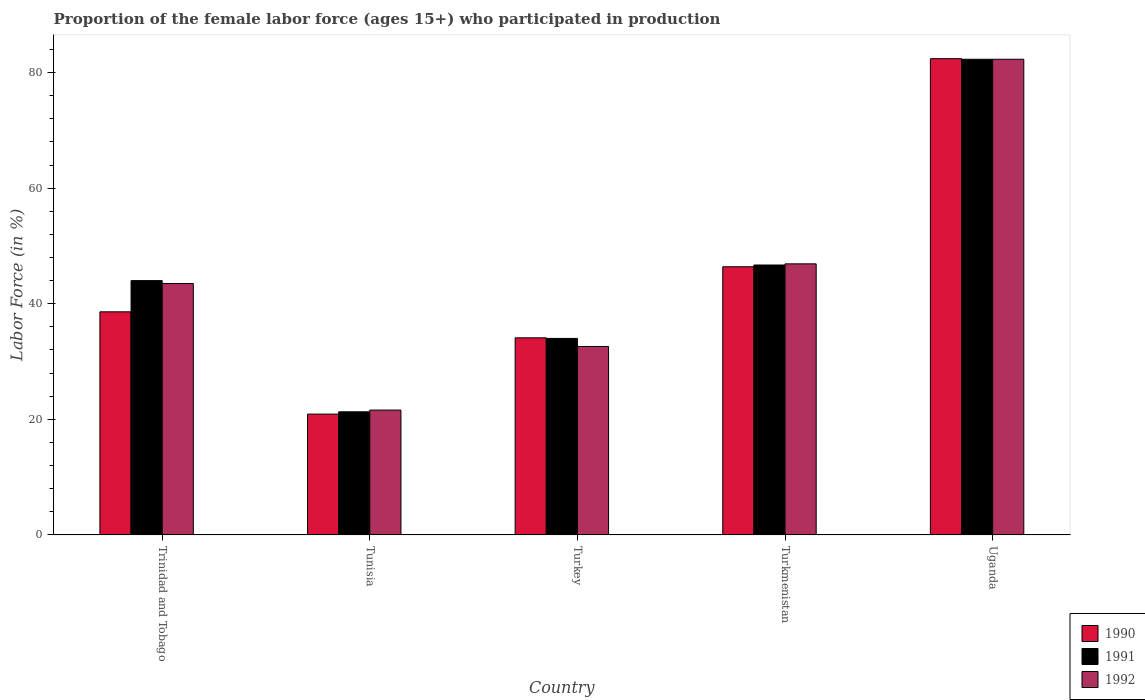How many different coloured bars are there?
Offer a very short reply. 3. How many groups of bars are there?
Keep it short and to the point. 5. What is the label of the 2nd group of bars from the left?
Your answer should be very brief. Tunisia. In how many cases, is the number of bars for a given country not equal to the number of legend labels?
Offer a terse response. 0. What is the proportion of the female labor force who participated in production in 1991 in Tunisia?
Your response must be concise. 21.3. Across all countries, what is the maximum proportion of the female labor force who participated in production in 1992?
Offer a terse response. 82.3. Across all countries, what is the minimum proportion of the female labor force who participated in production in 1990?
Keep it short and to the point. 20.9. In which country was the proportion of the female labor force who participated in production in 1991 maximum?
Offer a very short reply. Uganda. In which country was the proportion of the female labor force who participated in production in 1990 minimum?
Ensure brevity in your answer.  Tunisia. What is the total proportion of the female labor force who participated in production in 1991 in the graph?
Give a very brief answer. 228.3. What is the difference between the proportion of the female labor force who participated in production in 1992 in Turkey and that in Turkmenistan?
Your response must be concise. -14.3. What is the difference between the proportion of the female labor force who participated in production in 1990 in Trinidad and Tobago and the proportion of the female labor force who participated in production in 1991 in Turkmenistan?
Provide a succinct answer. -8.1. What is the average proportion of the female labor force who participated in production in 1990 per country?
Make the answer very short. 44.48. What is the difference between the proportion of the female labor force who participated in production of/in 1991 and proportion of the female labor force who participated in production of/in 1992 in Turkey?
Keep it short and to the point. 1.4. In how many countries, is the proportion of the female labor force who participated in production in 1992 greater than 4 %?
Make the answer very short. 5. What is the ratio of the proportion of the female labor force who participated in production in 1991 in Turkey to that in Uganda?
Make the answer very short. 0.41. Is the proportion of the female labor force who participated in production in 1991 in Turkey less than that in Turkmenistan?
Give a very brief answer. Yes. What is the difference between the highest and the second highest proportion of the female labor force who participated in production in 1991?
Give a very brief answer. 38.3. What is the difference between the highest and the lowest proportion of the female labor force who participated in production in 1990?
Ensure brevity in your answer.  61.5. What does the 1st bar from the right in Trinidad and Tobago represents?
Offer a very short reply. 1992. Is it the case that in every country, the sum of the proportion of the female labor force who participated in production in 1992 and proportion of the female labor force who participated in production in 1990 is greater than the proportion of the female labor force who participated in production in 1991?
Provide a short and direct response. Yes. Are all the bars in the graph horizontal?
Provide a short and direct response. No. How many countries are there in the graph?
Offer a terse response. 5. Does the graph contain any zero values?
Offer a terse response. No. Where does the legend appear in the graph?
Provide a succinct answer. Bottom right. How many legend labels are there?
Your answer should be very brief. 3. How are the legend labels stacked?
Make the answer very short. Vertical. What is the title of the graph?
Give a very brief answer. Proportion of the female labor force (ages 15+) who participated in production. Does "1965" appear as one of the legend labels in the graph?
Your answer should be compact. No. What is the label or title of the X-axis?
Offer a very short reply. Country. What is the Labor Force (in %) of 1990 in Trinidad and Tobago?
Offer a very short reply. 38.6. What is the Labor Force (in %) of 1992 in Trinidad and Tobago?
Offer a terse response. 43.5. What is the Labor Force (in %) in 1990 in Tunisia?
Ensure brevity in your answer.  20.9. What is the Labor Force (in %) of 1991 in Tunisia?
Provide a short and direct response. 21.3. What is the Labor Force (in %) of 1992 in Tunisia?
Make the answer very short. 21.6. What is the Labor Force (in %) of 1990 in Turkey?
Keep it short and to the point. 34.1. What is the Labor Force (in %) of 1991 in Turkey?
Ensure brevity in your answer.  34. What is the Labor Force (in %) in 1992 in Turkey?
Ensure brevity in your answer.  32.6. What is the Labor Force (in %) in 1990 in Turkmenistan?
Your answer should be very brief. 46.4. What is the Labor Force (in %) of 1991 in Turkmenistan?
Provide a short and direct response. 46.7. What is the Labor Force (in %) of 1992 in Turkmenistan?
Your answer should be compact. 46.9. What is the Labor Force (in %) in 1990 in Uganda?
Provide a succinct answer. 82.4. What is the Labor Force (in %) in 1991 in Uganda?
Provide a succinct answer. 82.3. What is the Labor Force (in %) in 1992 in Uganda?
Your answer should be very brief. 82.3. Across all countries, what is the maximum Labor Force (in %) in 1990?
Provide a succinct answer. 82.4. Across all countries, what is the maximum Labor Force (in %) in 1991?
Your answer should be compact. 82.3. Across all countries, what is the maximum Labor Force (in %) in 1992?
Your answer should be very brief. 82.3. Across all countries, what is the minimum Labor Force (in %) in 1990?
Make the answer very short. 20.9. Across all countries, what is the minimum Labor Force (in %) in 1991?
Keep it short and to the point. 21.3. Across all countries, what is the minimum Labor Force (in %) of 1992?
Your response must be concise. 21.6. What is the total Labor Force (in %) in 1990 in the graph?
Your answer should be very brief. 222.4. What is the total Labor Force (in %) in 1991 in the graph?
Give a very brief answer. 228.3. What is the total Labor Force (in %) of 1992 in the graph?
Your response must be concise. 226.9. What is the difference between the Labor Force (in %) in 1991 in Trinidad and Tobago and that in Tunisia?
Provide a short and direct response. 22.7. What is the difference between the Labor Force (in %) in 1992 in Trinidad and Tobago and that in Tunisia?
Your response must be concise. 21.9. What is the difference between the Labor Force (in %) of 1990 in Trinidad and Tobago and that in Turkey?
Your answer should be compact. 4.5. What is the difference between the Labor Force (in %) in 1991 in Trinidad and Tobago and that in Turkey?
Your response must be concise. 10. What is the difference between the Labor Force (in %) in 1991 in Trinidad and Tobago and that in Turkmenistan?
Your answer should be very brief. -2.7. What is the difference between the Labor Force (in %) of 1992 in Trinidad and Tobago and that in Turkmenistan?
Offer a very short reply. -3.4. What is the difference between the Labor Force (in %) in 1990 in Trinidad and Tobago and that in Uganda?
Offer a terse response. -43.8. What is the difference between the Labor Force (in %) in 1991 in Trinidad and Tobago and that in Uganda?
Your answer should be compact. -38.3. What is the difference between the Labor Force (in %) of 1992 in Trinidad and Tobago and that in Uganda?
Offer a very short reply. -38.8. What is the difference between the Labor Force (in %) in 1992 in Tunisia and that in Turkey?
Offer a terse response. -11. What is the difference between the Labor Force (in %) in 1990 in Tunisia and that in Turkmenistan?
Your answer should be compact. -25.5. What is the difference between the Labor Force (in %) in 1991 in Tunisia and that in Turkmenistan?
Give a very brief answer. -25.4. What is the difference between the Labor Force (in %) of 1992 in Tunisia and that in Turkmenistan?
Offer a terse response. -25.3. What is the difference between the Labor Force (in %) of 1990 in Tunisia and that in Uganda?
Provide a succinct answer. -61.5. What is the difference between the Labor Force (in %) of 1991 in Tunisia and that in Uganda?
Ensure brevity in your answer.  -61. What is the difference between the Labor Force (in %) of 1992 in Tunisia and that in Uganda?
Your answer should be very brief. -60.7. What is the difference between the Labor Force (in %) in 1992 in Turkey and that in Turkmenistan?
Give a very brief answer. -14.3. What is the difference between the Labor Force (in %) in 1990 in Turkey and that in Uganda?
Your answer should be very brief. -48.3. What is the difference between the Labor Force (in %) in 1991 in Turkey and that in Uganda?
Keep it short and to the point. -48.3. What is the difference between the Labor Force (in %) of 1992 in Turkey and that in Uganda?
Offer a terse response. -49.7. What is the difference between the Labor Force (in %) in 1990 in Turkmenistan and that in Uganda?
Provide a short and direct response. -36. What is the difference between the Labor Force (in %) in 1991 in Turkmenistan and that in Uganda?
Provide a succinct answer. -35.6. What is the difference between the Labor Force (in %) of 1992 in Turkmenistan and that in Uganda?
Your answer should be very brief. -35.4. What is the difference between the Labor Force (in %) of 1990 in Trinidad and Tobago and the Labor Force (in %) of 1991 in Tunisia?
Offer a very short reply. 17.3. What is the difference between the Labor Force (in %) in 1990 in Trinidad and Tobago and the Labor Force (in %) in 1992 in Tunisia?
Offer a terse response. 17. What is the difference between the Labor Force (in %) of 1991 in Trinidad and Tobago and the Labor Force (in %) of 1992 in Tunisia?
Offer a very short reply. 22.4. What is the difference between the Labor Force (in %) in 1990 in Trinidad and Tobago and the Labor Force (in %) in 1991 in Turkey?
Offer a very short reply. 4.6. What is the difference between the Labor Force (in %) of 1991 in Trinidad and Tobago and the Labor Force (in %) of 1992 in Turkey?
Your answer should be compact. 11.4. What is the difference between the Labor Force (in %) in 1990 in Trinidad and Tobago and the Labor Force (in %) in 1992 in Turkmenistan?
Ensure brevity in your answer.  -8.3. What is the difference between the Labor Force (in %) in 1991 in Trinidad and Tobago and the Labor Force (in %) in 1992 in Turkmenistan?
Ensure brevity in your answer.  -2.9. What is the difference between the Labor Force (in %) in 1990 in Trinidad and Tobago and the Labor Force (in %) in 1991 in Uganda?
Provide a succinct answer. -43.7. What is the difference between the Labor Force (in %) in 1990 in Trinidad and Tobago and the Labor Force (in %) in 1992 in Uganda?
Make the answer very short. -43.7. What is the difference between the Labor Force (in %) of 1991 in Trinidad and Tobago and the Labor Force (in %) of 1992 in Uganda?
Offer a terse response. -38.3. What is the difference between the Labor Force (in %) of 1990 in Tunisia and the Labor Force (in %) of 1991 in Turkey?
Give a very brief answer. -13.1. What is the difference between the Labor Force (in %) of 1991 in Tunisia and the Labor Force (in %) of 1992 in Turkey?
Make the answer very short. -11.3. What is the difference between the Labor Force (in %) of 1990 in Tunisia and the Labor Force (in %) of 1991 in Turkmenistan?
Your response must be concise. -25.8. What is the difference between the Labor Force (in %) in 1991 in Tunisia and the Labor Force (in %) in 1992 in Turkmenistan?
Your response must be concise. -25.6. What is the difference between the Labor Force (in %) of 1990 in Tunisia and the Labor Force (in %) of 1991 in Uganda?
Your response must be concise. -61.4. What is the difference between the Labor Force (in %) of 1990 in Tunisia and the Labor Force (in %) of 1992 in Uganda?
Your response must be concise. -61.4. What is the difference between the Labor Force (in %) in 1991 in Tunisia and the Labor Force (in %) in 1992 in Uganda?
Your answer should be compact. -61. What is the difference between the Labor Force (in %) in 1990 in Turkey and the Labor Force (in %) in 1991 in Turkmenistan?
Ensure brevity in your answer.  -12.6. What is the difference between the Labor Force (in %) of 1991 in Turkey and the Labor Force (in %) of 1992 in Turkmenistan?
Keep it short and to the point. -12.9. What is the difference between the Labor Force (in %) in 1990 in Turkey and the Labor Force (in %) in 1991 in Uganda?
Your answer should be very brief. -48.2. What is the difference between the Labor Force (in %) of 1990 in Turkey and the Labor Force (in %) of 1992 in Uganda?
Keep it short and to the point. -48.2. What is the difference between the Labor Force (in %) of 1991 in Turkey and the Labor Force (in %) of 1992 in Uganda?
Your response must be concise. -48.3. What is the difference between the Labor Force (in %) in 1990 in Turkmenistan and the Labor Force (in %) in 1991 in Uganda?
Make the answer very short. -35.9. What is the difference between the Labor Force (in %) of 1990 in Turkmenistan and the Labor Force (in %) of 1992 in Uganda?
Ensure brevity in your answer.  -35.9. What is the difference between the Labor Force (in %) of 1991 in Turkmenistan and the Labor Force (in %) of 1992 in Uganda?
Give a very brief answer. -35.6. What is the average Labor Force (in %) of 1990 per country?
Offer a terse response. 44.48. What is the average Labor Force (in %) of 1991 per country?
Give a very brief answer. 45.66. What is the average Labor Force (in %) in 1992 per country?
Offer a terse response. 45.38. What is the difference between the Labor Force (in %) of 1990 and Labor Force (in %) of 1991 in Trinidad and Tobago?
Ensure brevity in your answer.  -5.4. What is the difference between the Labor Force (in %) in 1991 and Labor Force (in %) in 1992 in Tunisia?
Your answer should be compact. -0.3. What is the difference between the Labor Force (in %) in 1990 and Labor Force (in %) in 1991 in Turkey?
Keep it short and to the point. 0.1. What is the difference between the Labor Force (in %) in 1991 and Labor Force (in %) in 1992 in Turkey?
Your answer should be compact. 1.4. What is the difference between the Labor Force (in %) in 1991 and Labor Force (in %) in 1992 in Turkmenistan?
Your answer should be compact. -0.2. What is the difference between the Labor Force (in %) of 1990 and Labor Force (in %) of 1992 in Uganda?
Keep it short and to the point. 0.1. What is the difference between the Labor Force (in %) of 1991 and Labor Force (in %) of 1992 in Uganda?
Give a very brief answer. 0. What is the ratio of the Labor Force (in %) in 1990 in Trinidad and Tobago to that in Tunisia?
Give a very brief answer. 1.85. What is the ratio of the Labor Force (in %) of 1991 in Trinidad and Tobago to that in Tunisia?
Your answer should be very brief. 2.07. What is the ratio of the Labor Force (in %) in 1992 in Trinidad and Tobago to that in Tunisia?
Provide a succinct answer. 2.01. What is the ratio of the Labor Force (in %) in 1990 in Trinidad and Tobago to that in Turkey?
Give a very brief answer. 1.13. What is the ratio of the Labor Force (in %) in 1991 in Trinidad and Tobago to that in Turkey?
Make the answer very short. 1.29. What is the ratio of the Labor Force (in %) in 1992 in Trinidad and Tobago to that in Turkey?
Your answer should be compact. 1.33. What is the ratio of the Labor Force (in %) in 1990 in Trinidad and Tobago to that in Turkmenistan?
Your answer should be very brief. 0.83. What is the ratio of the Labor Force (in %) of 1991 in Trinidad and Tobago to that in Turkmenistan?
Give a very brief answer. 0.94. What is the ratio of the Labor Force (in %) in 1992 in Trinidad and Tobago to that in Turkmenistan?
Ensure brevity in your answer.  0.93. What is the ratio of the Labor Force (in %) in 1990 in Trinidad and Tobago to that in Uganda?
Give a very brief answer. 0.47. What is the ratio of the Labor Force (in %) in 1991 in Trinidad and Tobago to that in Uganda?
Offer a very short reply. 0.53. What is the ratio of the Labor Force (in %) of 1992 in Trinidad and Tobago to that in Uganda?
Your answer should be compact. 0.53. What is the ratio of the Labor Force (in %) of 1990 in Tunisia to that in Turkey?
Give a very brief answer. 0.61. What is the ratio of the Labor Force (in %) in 1991 in Tunisia to that in Turkey?
Your response must be concise. 0.63. What is the ratio of the Labor Force (in %) of 1992 in Tunisia to that in Turkey?
Your answer should be compact. 0.66. What is the ratio of the Labor Force (in %) of 1990 in Tunisia to that in Turkmenistan?
Your answer should be very brief. 0.45. What is the ratio of the Labor Force (in %) in 1991 in Tunisia to that in Turkmenistan?
Provide a short and direct response. 0.46. What is the ratio of the Labor Force (in %) in 1992 in Tunisia to that in Turkmenistan?
Make the answer very short. 0.46. What is the ratio of the Labor Force (in %) of 1990 in Tunisia to that in Uganda?
Ensure brevity in your answer.  0.25. What is the ratio of the Labor Force (in %) of 1991 in Tunisia to that in Uganda?
Offer a terse response. 0.26. What is the ratio of the Labor Force (in %) in 1992 in Tunisia to that in Uganda?
Offer a terse response. 0.26. What is the ratio of the Labor Force (in %) in 1990 in Turkey to that in Turkmenistan?
Provide a short and direct response. 0.73. What is the ratio of the Labor Force (in %) of 1991 in Turkey to that in Turkmenistan?
Offer a very short reply. 0.73. What is the ratio of the Labor Force (in %) in 1992 in Turkey to that in Turkmenistan?
Your answer should be very brief. 0.7. What is the ratio of the Labor Force (in %) of 1990 in Turkey to that in Uganda?
Your response must be concise. 0.41. What is the ratio of the Labor Force (in %) in 1991 in Turkey to that in Uganda?
Make the answer very short. 0.41. What is the ratio of the Labor Force (in %) of 1992 in Turkey to that in Uganda?
Provide a short and direct response. 0.4. What is the ratio of the Labor Force (in %) of 1990 in Turkmenistan to that in Uganda?
Offer a very short reply. 0.56. What is the ratio of the Labor Force (in %) of 1991 in Turkmenistan to that in Uganda?
Your answer should be compact. 0.57. What is the ratio of the Labor Force (in %) of 1992 in Turkmenistan to that in Uganda?
Ensure brevity in your answer.  0.57. What is the difference between the highest and the second highest Labor Force (in %) of 1991?
Your response must be concise. 35.6. What is the difference between the highest and the second highest Labor Force (in %) in 1992?
Your answer should be very brief. 35.4. What is the difference between the highest and the lowest Labor Force (in %) of 1990?
Provide a succinct answer. 61.5. What is the difference between the highest and the lowest Labor Force (in %) in 1992?
Offer a terse response. 60.7. 